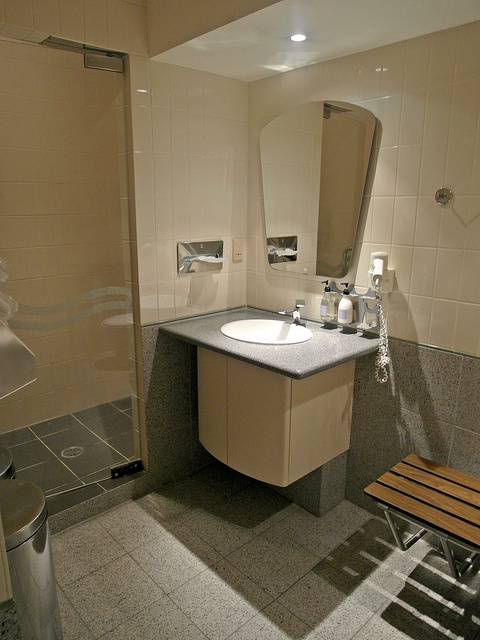Describe the objects in this image and their specific colors. I can see bench in olive, black, and gray tones, sink in olive, white, darkgray, and gray tones, bottle in olive, darkgray, gray, and tan tones, bottle in olive, lightgray, darkgray, black, and gray tones, and hair drier in olive, white, gray, and darkgray tones in this image. 